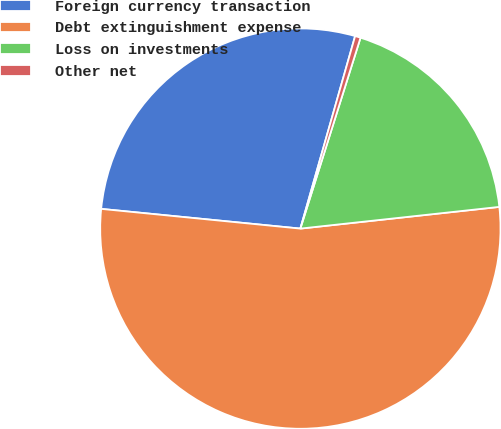Convert chart. <chart><loc_0><loc_0><loc_500><loc_500><pie_chart><fcel>Foreign currency transaction<fcel>Debt extinguishment expense<fcel>Loss on investments<fcel>Other net<nl><fcel>27.84%<fcel>53.3%<fcel>18.41%<fcel>0.45%<nl></chart> 